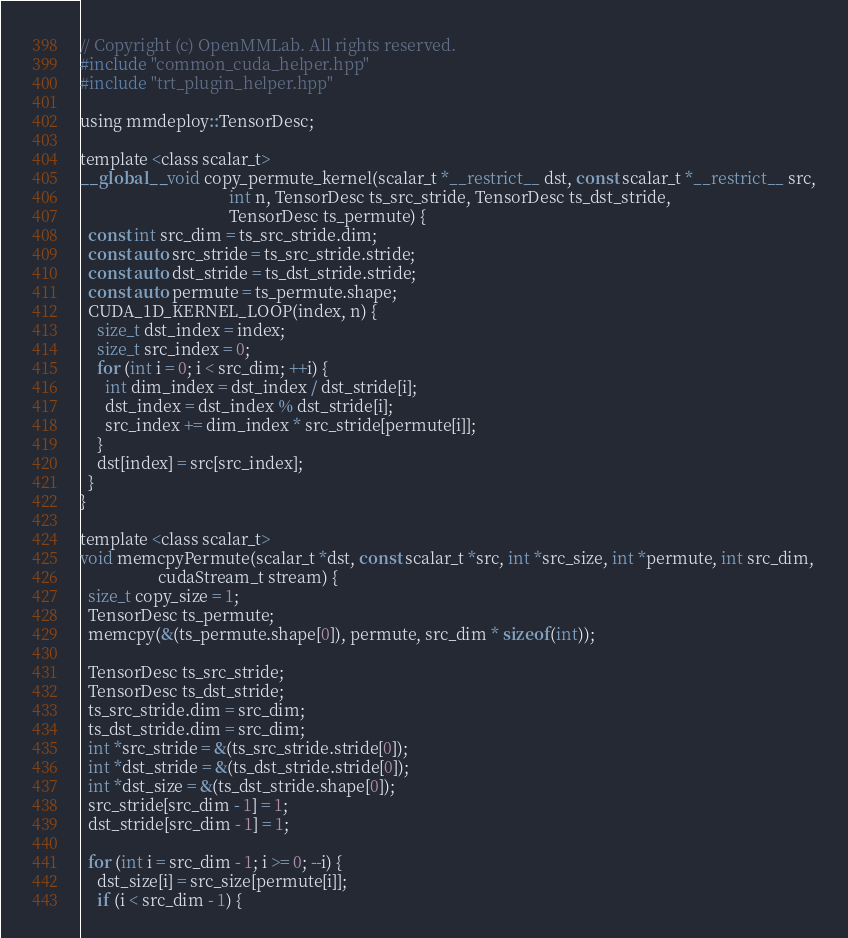Convert code to text. <code><loc_0><loc_0><loc_500><loc_500><_Cuda_>// Copyright (c) OpenMMLab. All rights reserved.
#include "common_cuda_helper.hpp"
#include "trt_plugin_helper.hpp"

using mmdeploy::TensorDesc;

template <class scalar_t>
__global__ void copy_permute_kernel(scalar_t *__restrict__ dst, const scalar_t *__restrict__ src,
                                    int n, TensorDesc ts_src_stride, TensorDesc ts_dst_stride,
                                    TensorDesc ts_permute) {
  const int src_dim = ts_src_stride.dim;
  const auto src_stride = ts_src_stride.stride;
  const auto dst_stride = ts_dst_stride.stride;
  const auto permute = ts_permute.shape;
  CUDA_1D_KERNEL_LOOP(index, n) {
    size_t dst_index = index;
    size_t src_index = 0;
    for (int i = 0; i < src_dim; ++i) {
      int dim_index = dst_index / dst_stride[i];
      dst_index = dst_index % dst_stride[i];
      src_index += dim_index * src_stride[permute[i]];
    }
    dst[index] = src[src_index];
  }
}

template <class scalar_t>
void memcpyPermute(scalar_t *dst, const scalar_t *src, int *src_size, int *permute, int src_dim,
                   cudaStream_t stream) {
  size_t copy_size = 1;
  TensorDesc ts_permute;
  memcpy(&(ts_permute.shape[0]), permute, src_dim * sizeof(int));

  TensorDesc ts_src_stride;
  TensorDesc ts_dst_stride;
  ts_src_stride.dim = src_dim;
  ts_dst_stride.dim = src_dim;
  int *src_stride = &(ts_src_stride.stride[0]);
  int *dst_stride = &(ts_dst_stride.stride[0]);
  int *dst_size = &(ts_dst_stride.shape[0]);
  src_stride[src_dim - 1] = 1;
  dst_stride[src_dim - 1] = 1;

  for (int i = src_dim - 1; i >= 0; --i) {
    dst_size[i] = src_size[permute[i]];
    if (i < src_dim - 1) {</code> 